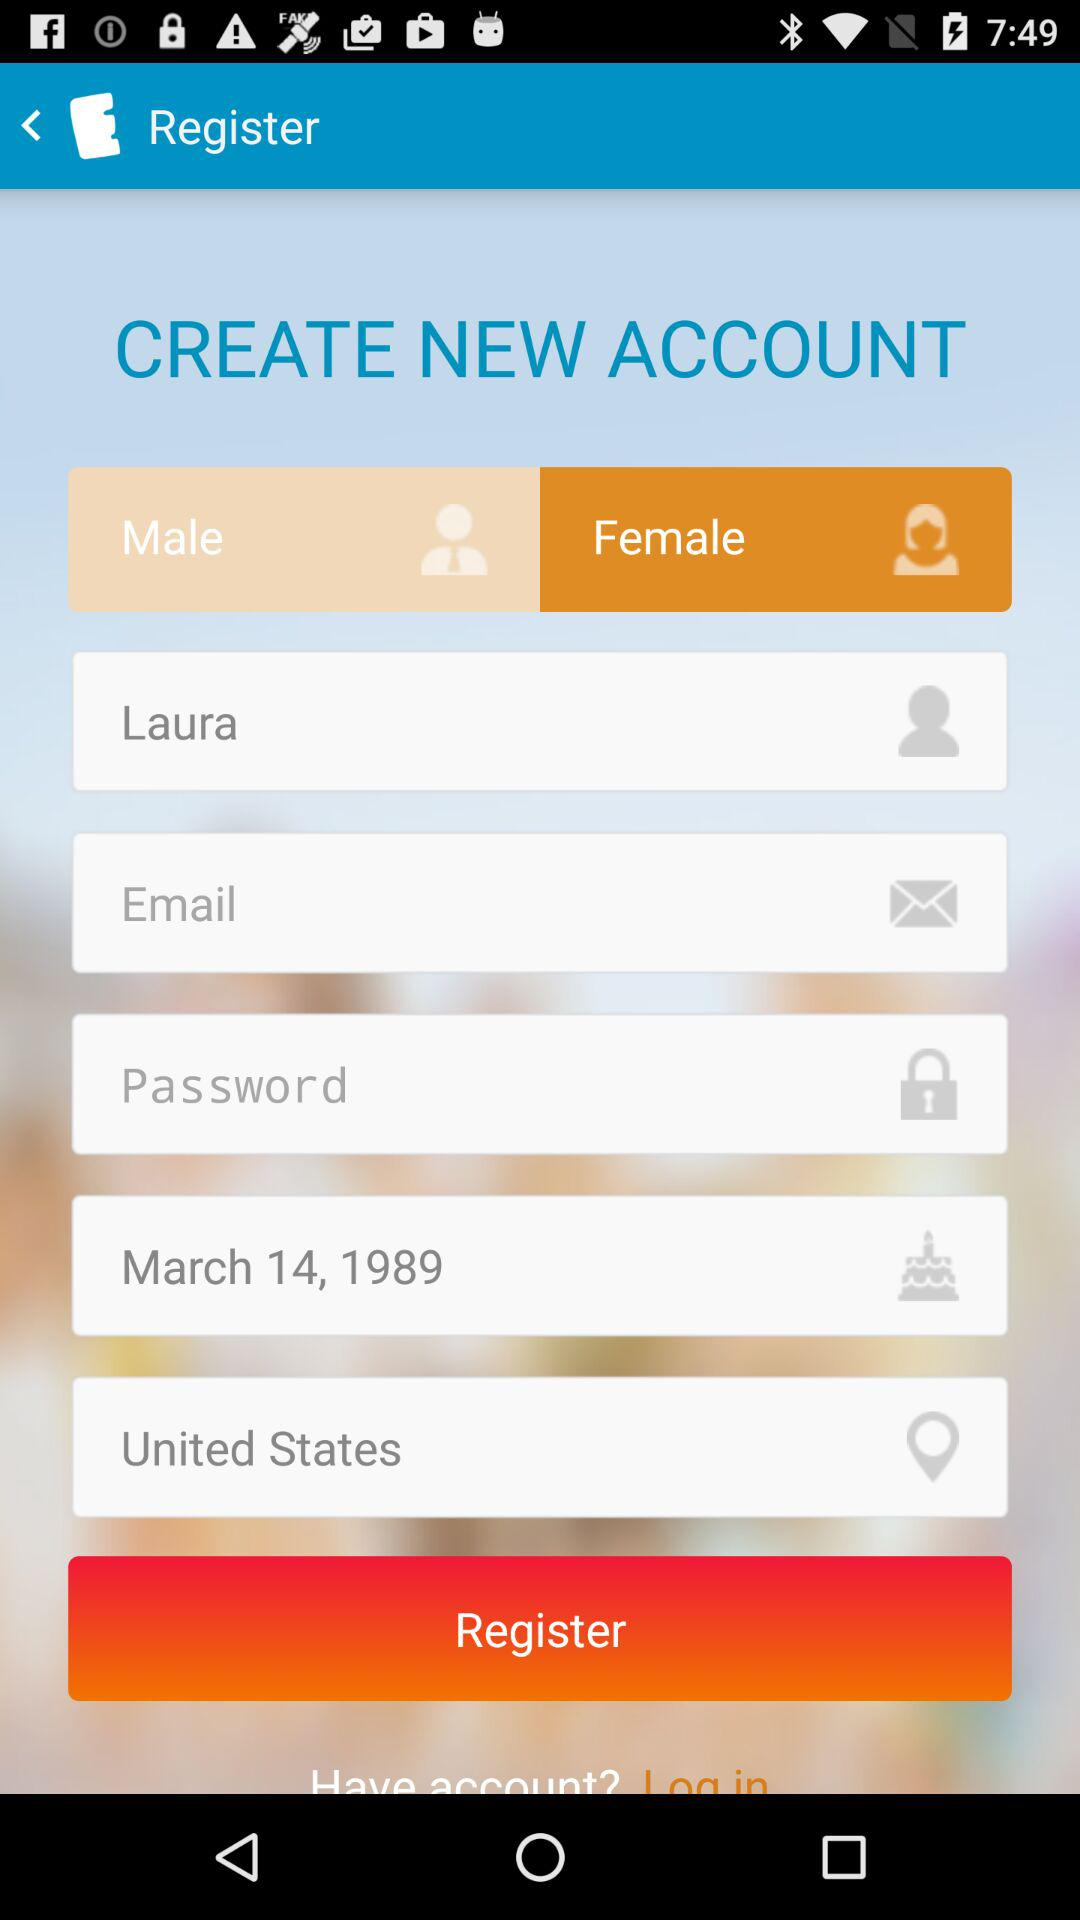What is the date of birth of the user? The date of birth is March 14, 1989. 